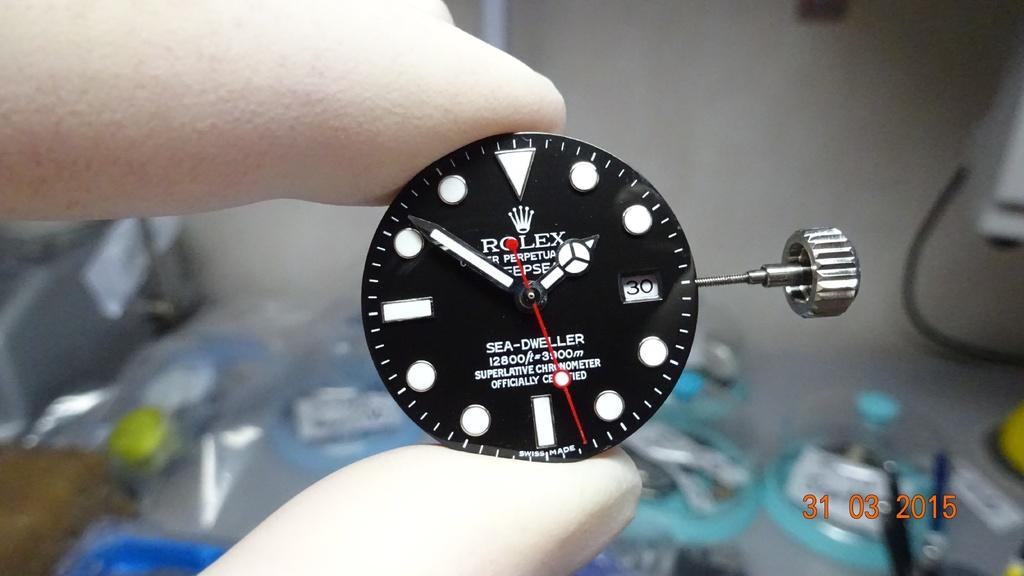<image>
Share a concise interpretation of the image provided. Someone wearing gloves is holding the face component of a Rolex wrist watch. 